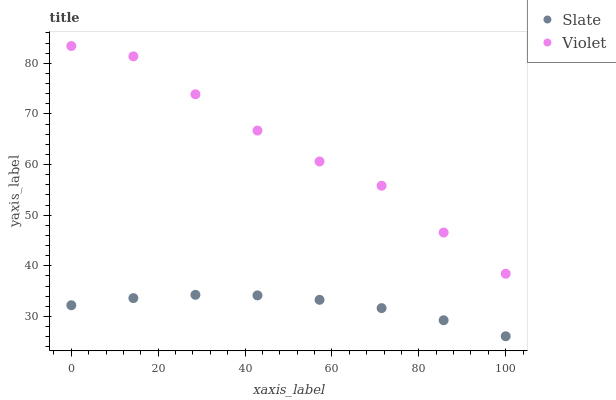Does Slate have the minimum area under the curve?
Answer yes or no. Yes. Does Violet have the maximum area under the curve?
Answer yes or no. Yes. Does Violet have the minimum area under the curve?
Answer yes or no. No. Is Slate the smoothest?
Answer yes or no. Yes. Is Violet the roughest?
Answer yes or no. Yes. Is Violet the smoothest?
Answer yes or no. No. Does Slate have the lowest value?
Answer yes or no. Yes. Does Violet have the lowest value?
Answer yes or no. No. Does Violet have the highest value?
Answer yes or no. Yes. Is Slate less than Violet?
Answer yes or no. Yes. Is Violet greater than Slate?
Answer yes or no. Yes. Does Slate intersect Violet?
Answer yes or no. No. 